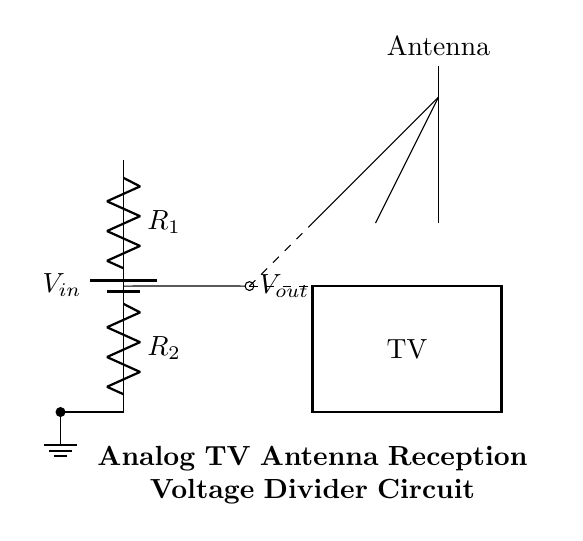What components are present in this circuit? The circuit contains a battery, two resistors, an antenna, and a TV.
Answer: Battery, resistors, antenna, TV What is the purpose of the resistors in this circuit? The resistors form a voltage divider, which adjusts the output voltage for optimal antenna reception.
Answer: Voltage divider How is the output voltage labeled in the circuit? The output voltage is labeled as V out, indicating the voltage coming from the junction of the two resistors.
Answer: V out What happens to the voltage as it passes through the resistors? The voltage decreases from the input voltage V in to the output voltage V out based on the resistor values.
Answer: Decreases How does the antenna connect to the circuit? The antenna is connected to the output node at V out, which allows it to receive the adjusted voltage for TV signals.
Answer: At V out What is the input voltage in this circuit? The input voltage is labeled as V in, which is the supply voltage for the circuit.
Answer: V in Which resistor is positioned above the other? Resistor R1 is positioned above resistor R2 in the circuit diagram.
Answer: R1 